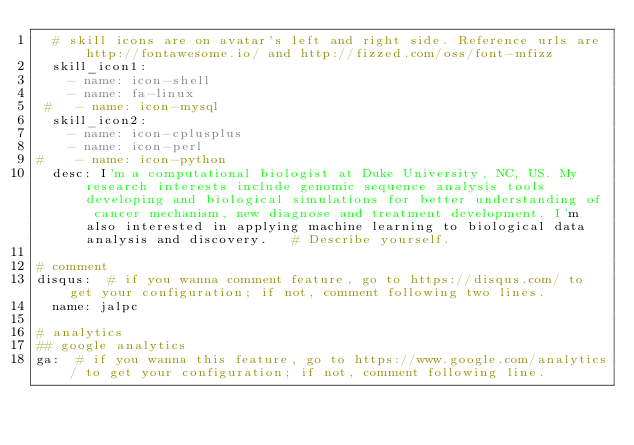<code> <loc_0><loc_0><loc_500><loc_500><_YAML_>  # skill icons are on avatar's left and right side. Reference urls are http://fontawesome.io/ and http://fizzed.com/oss/font-mfizz
  skill_icon1:
    - name: icon-shell
    - name: fa-linux
 #   - name: icon-mysql
  skill_icon2:
    - name: icon-cplusplus
    - name: icon-perl
#    - name: icon-python
  desc: I'm a computational biologist at Duke University, NC, US. My research interests include genomic sequence analysis tools developing and biological simulations for better understanding of cancer mechanism, new diagnose and treatment development. I'm also interested in applying machine learning to biological data analysis and discovery.   # Describe yourself.

# comment
disqus:  # if you wanna comment feature, go to https://disqus.com/ to get your configuration; if not, comment following two lines.
  name: jalpc

# analytics
## google analytics
ga:  # if you wanna this feature, go to https://www.google.com/analytics/ to get your configuration; if not, comment following line.</code> 